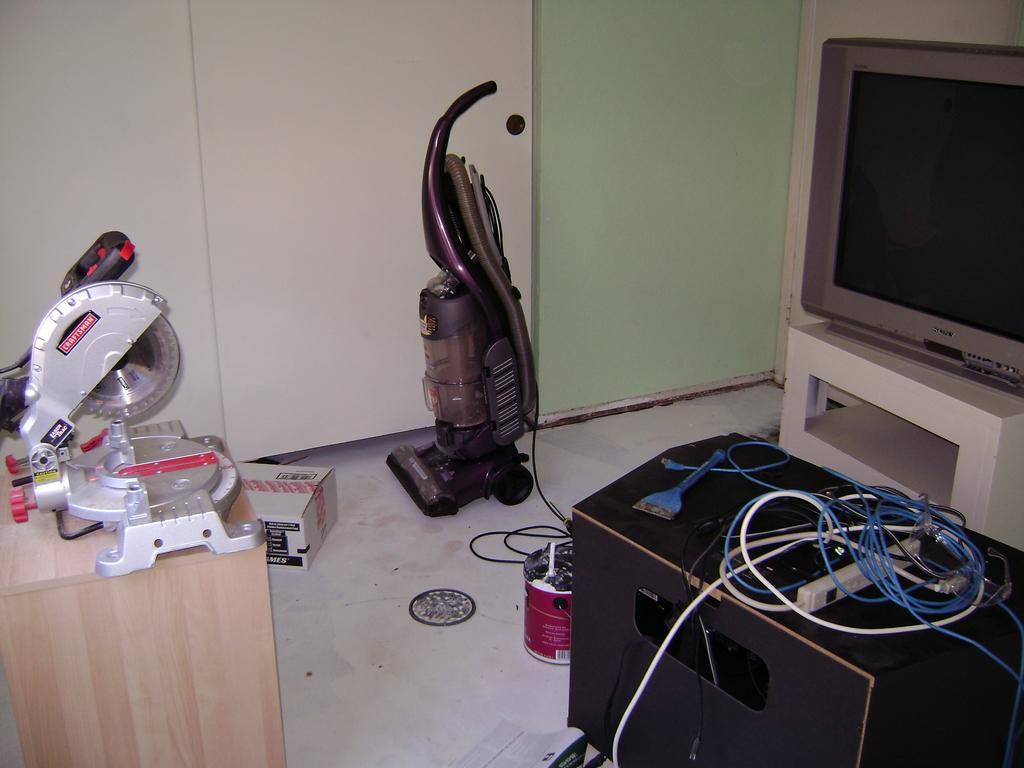Please provide a concise description of this image. In this image I can see few electronic gadgets in different colors. I can see a television,cardboard box,wall and few objects. 